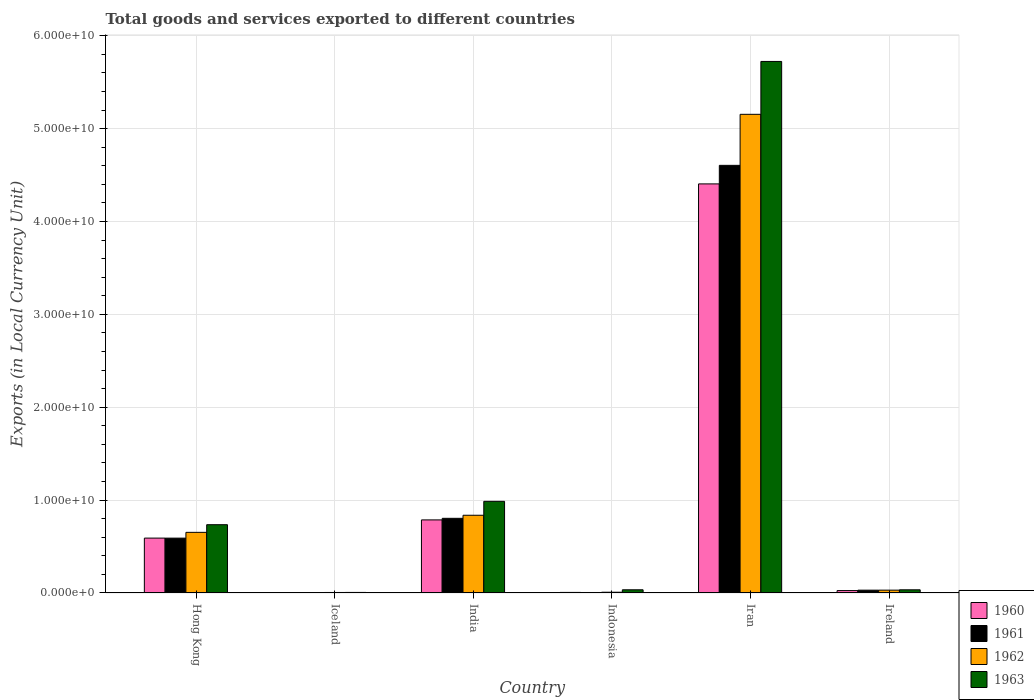How many different coloured bars are there?
Offer a very short reply. 4. How many groups of bars are there?
Your answer should be very brief. 6. Are the number of bars per tick equal to the number of legend labels?
Your answer should be compact. Yes. Are the number of bars on each tick of the X-axis equal?
Provide a short and direct response. Yes. How many bars are there on the 4th tick from the left?
Provide a succinct answer. 4. How many bars are there on the 1st tick from the right?
Provide a short and direct response. 4. What is the label of the 1st group of bars from the left?
Offer a very short reply. Hong Kong. In how many cases, is the number of bars for a given country not equal to the number of legend labels?
Make the answer very short. 0. What is the Amount of goods and services exports in 1963 in Iran?
Make the answer very short. 5.72e+1. Across all countries, what is the maximum Amount of goods and services exports in 1962?
Keep it short and to the point. 5.15e+1. Across all countries, what is the minimum Amount of goods and services exports in 1963?
Your response must be concise. 6.02e+07. In which country was the Amount of goods and services exports in 1960 maximum?
Ensure brevity in your answer.  Iran. In which country was the Amount of goods and services exports in 1960 minimum?
Provide a short and direct response. Iceland. What is the total Amount of goods and services exports in 1963 in the graph?
Your answer should be compact. 7.52e+1. What is the difference between the Amount of goods and services exports in 1961 in Indonesia and that in Iran?
Keep it short and to the point. -4.60e+1. What is the difference between the Amount of goods and services exports in 1960 in Ireland and the Amount of goods and services exports in 1962 in Hong Kong?
Ensure brevity in your answer.  -6.27e+09. What is the average Amount of goods and services exports in 1961 per country?
Keep it short and to the point. 1.01e+1. What is the difference between the Amount of goods and services exports of/in 1963 and Amount of goods and services exports of/in 1960 in Hong Kong?
Offer a terse response. 1.44e+09. What is the ratio of the Amount of goods and services exports in 1961 in Hong Kong to that in Iceland?
Provide a short and direct response. 140.21. What is the difference between the highest and the second highest Amount of goods and services exports in 1963?
Keep it short and to the point. -4.74e+1. What is the difference between the highest and the lowest Amount of goods and services exports in 1962?
Your answer should be compact. 5.15e+1. What does the 4th bar from the left in Indonesia represents?
Your answer should be very brief. 1963. What does the 1st bar from the right in Iran represents?
Provide a succinct answer. 1963. Is it the case that in every country, the sum of the Amount of goods and services exports in 1961 and Amount of goods and services exports in 1962 is greater than the Amount of goods and services exports in 1963?
Offer a terse response. No. Are all the bars in the graph horizontal?
Offer a terse response. No. Does the graph contain grids?
Provide a succinct answer. Yes. Where does the legend appear in the graph?
Ensure brevity in your answer.  Bottom right. How are the legend labels stacked?
Make the answer very short. Vertical. What is the title of the graph?
Ensure brevity in your answer.  Total goods and services exported to different countries. Does "1964" appear as one of the legend labels in the graph?
Make the answer very short. No. What is the label or title of the X-axis?
Ensure brevity in your answer.  Country. What is the label or title of the Y-axis?
Your response must be concise. Exports (in Local Currency Unit). What is the Exports (in Local Currency Unit) of 1960 in Hong Kong?
Keep it short and to the point. 5.91e+09. What is the Exports (in Local Currency Unit) of 1961 in Hong Kong?
Make the answer very short. 5.91e+09. What is the Exports (in Local Currency Unit) in 1962 in Hong Kong?
Provide a short and direct response. 6.53e+09. What is the Exports (in Local Currency Unit) in 1963 in Hong Kong?
Your answer should be very brief. 7.35e+09. What is the Exports (in Local Currency Unit) in 1960 in Iceland?
Provide a short and direct response. 3.71e+07. What is the Exports (in Local Currency Unit) of 1961 in Iceland?
Offer a terse response. 4.21e+07. What is the Exports (in Local Currency Unit) of 1962 in Iceland?
Your answer should be compact. 5.52e+07. What is the Exports (in Local Currency Unit) of 1963 in Iceland?
Your answer should be compact. 6.02e+07. What is the Exports (in Local Currency Unit) of 1960 in India?
Your response must be concise. 7.87e+09. What is the Exports (in Local Currency Unit) of 1961 in India?
Offer a terse response. 8.04e+09. What is the Exports (in Local Currency Unit) of 1962 in India?
Ensure brevity in your answer.  8.37e+09. What is the Exports (in Local Currency Unit) in 1963 in India?
Your answer should be very brief. 9.87e+09. What is the Exports (in Local Currency Unit) of 1960 in Indonesia?
Offer a very short reply. 6.20e+07. What is the Exports (in Local Currency Unit) of 1961 in Indonesia?
Ensure brevity in your answer.  5.31e+07. What is the Exports (in Local Currency Unit) of 1962 in Indonesia?
Provide a short and direct response. 8.19e+07. What is the Exports (in Local Currency Unit) of 1963 in Indonesia?
Provide a short and direct response. 3.44e+08. What is the Exports (in Local Currency Unit) of 1960 in Iran?
Provide a short and direct response. 4.41e+1. What is the Exports (in Local Currency Unit) of 1961 in Iran?
Offer a very short reply. 4.60e+1. What is the Exports (in Local Currency Unit) of 1962 in Iran?
Offer a very short reply. 5.15e+1. What is the Exports (in Local Currency Unit) of 1963 in Iran?
Offer a very short reply. 5.72e+1. What is the Exports (in Local Currency Unit) of 1960 in Ireland?
Give a very brief answer. 2.60e+08. What is the Exports (in Local Currency Unit) of 1961 in Ireland?
Keep it short and to the point. 3.04e+08. What is the Exports (in Local Currency Unit) in 1962 in Ireland?
Your answer should be very brief. 3.07e+08. What is the Exports (in Local Currency Unit) in 1963 in Ireland?
Offer a terse response. 3.43e+08. Across all countries, what is the maximum Exports (in Local Currency Unit) in 1960?
Provide a short and direct response. 4.41e+1. Across all countries, what is the maximum Exports (in Local Currency Unit) in 1961?
Your answer should be compact. 4.60e+1. Across all countries, what is the maximum Exports (in Local Currency Unit) of 1962?
Your answer should be very brief. 5.15e+1. Across all countries, what is the maximum Exports (in Local Currency Unit) of 1963?
Ensure brevity in your answer.  5.72e+1. Across all countries, what is the minimum Exports (in Local Currency Unit) in 1960?
Ensure brevity in your answer.  3.71e+07. Across all countries, what is the minimum Exports (in Local Currency Unit) in 1961?
Your response must be concise. 4.21e+07. Across all countries, what is the minimum Exports (in Local Currency Unit) in 1962?
Provide a short and direct response. 5.52e+07. Across all countries, what is the minimum Exports (in Local Currency Unit) in 1963?
Ensure brevity in your answer.  6.02e+07. What is the total Exports (in Local Currency Unit) of 1960 in the graph?
Offer a terse response. 5.82e+1. What is the total Exports (in Local Currency Unit) in 1961 in the graph?
Give a very brief answer. 6.04e+1. What is the total Exports (in Local Currency Unit) of 1962 in the graph?
Your answer should be very brief. 6.69e+1. What is the total Exports (in Local Currency Unit) of 1963 in the graph?
Keep it short and to the point. 7.52e+1. What is the difference between the Exports (in Local Currency Unit) in 1960 in Hong Kong and that in Iceland?
Provide a succinct answer. 5.87e+09. What is the difference between the Exports (in Local Currency Unit) of 1961 in Hong Kong and that in Iceland?
Provide a short and direct response. 5.87e+09. What is the difference between the Exports (in Local Currency Unit) in 1962 in Hong Kong and that in Iceland?
Your response must be concise. 6.47e+09. What is the difference between the Exports (in Local Currency Unit) in 1963 in Hong Kong and that in Iceland?
Your response must be concise. 7.29e+09. What is the difference between the Exports (in Local Currency Unit) of 1960 in Hong Kong and that in India?
Offer a very short reply. -1.96e+09. What is the difference between the Exports (in Local Currency Unit) in 1961 in Hong Kong and that in India?
Give a very brief answer. -2.13e+09. What is the difference between the Exports (in Local Currency Unit) of 1962 in Hong Kong and that in India?
Make the answer very short. -1.84e+09. What is the difference between the Exports (in Local Currency Unit) in 1963 in Hong Kong and that in India?
Make the answer very short. -2.52e+09. What is the difference between the Exports (in Local Currency Unit) in 1960 in Hong Kong and that in Indonesia?
Give a very brief answer. 5.85e+09. What is the difference between the Exports (in Local Currency Unit) in 1961 in Hong Kong and that in Indonesia?
Your response must be concise. 5.85e+09. What is the difference between the Exports (in Local Currency Unit) in 1962 in Hong Kong and that in Indonesia?
Keep it short and to the point. 6.45e+09. What is the difference between the Exports (in Local Currency Unit) in 1963 in Hong Kong and that in Indonesia?
Make the answer very short. 7.01e+09. What is the difference between the Exports (in Local Currency Unit) in 1960 in Hong Kong and that in Iran?
Your answer should be very brief. -3.81e+1. What is the difference between the Exports (in Local Currency Unit) of 1961 in Hong Kong and that in Iran?
Offer a very short reply. -4.01e+1. What is the difference between the Exports (in Local Currency Unit) of 1962 in Hong Kong and that in Iran?
Your answer should be very brief. -4.50e+1. What is the difference between the Exports (in Local Currency Unit) of 1963 in Hong Kong and that in Iran?
Provide a short and direct response. -4.99e+1. What is the difference between the Exports (in Local Currency Unit) of 1960 in Hong Kong and that in Ireland?
Keep it short and to the point. 5.65e+09. What is the difference between the Exports (in Local Currency Unit) in 1961 in Hong Kong and that in Ireland?
Your response must be concise. 5.60e+09. What is the difference between the Exports (in Local Currency Unit) of 1962 in Hong Kong and that in Ireland?
Your response must be concise. 6.22e+09. What is the difference between the Exports (in Local Currency Unit) of 1963 in Hong Kong and that in Ireland?
Your response must be concise. 7.01e+09. What is the difference between the Exports (in Local Currency Unit) of 1960 in Iceland and that in India?
Ensure brevity in your answer.  -7.83e+09. What is the difference between the Exports (in Local Currency Unit) of 1961 in Iceland and that in India?
Your response must be concise. -8.00e+09. What is the difference between the Exports (in Local Currency Unit) in 1962 in Iceland and that in India?
Provide a short and direct response. -8.31e+09. What is the difference between the Exports (in Local Currency Unit) of 1963 in Iceland and that in India?
Provide a short and direct response. -9.81e+09. What is the difference between the Exports (in Local Currency Unit) in 1960 in Iceland and that in Indonesia?
Keep it short and to the point. -2.49e+07. What is the difference between the Exports (in Local Currency Unit) of 1961 in Iceland and that in Indonesia?
Keep it short and to the point. -1.10e+07. What is the difference between the Exports (in Local Currency Unit) in 1962 in Iceland and that in Indonesia?
Your response must be concise. -2.67e+07. What is the difference between the Exports (in Local Currency Unit) in 1963 in Iceland and that in Indonesia?
Provide a short and direct response. -2.84e+08. What is the difference between the Exports (in Local Currency Unit) of 1960 in Iceland and that in Iran?
Provide a short and direct response. -4.40e+1. What is the difference between the Exports (in Local Currency Unit) of 1961 in Iceland and that in Iran?
Ensure brevity in your answer.  -4.60e+1. What is the difference between the Exports (in Local Currency Unit) of 1962 in Iceland and that in Iran?
Provide a succinct answer. -5.15e+1. What is the difference between the Exports (in Local Currency Unit) of 1963 in Iceland and that in Iran?
Provide a short and direct response. -5.72e+1. What is the difference between the Exports (in Local Currency Unit) in 1960 in Iceland and that in Ireland?
Your answer should be compact. -2.23e+08. What is the difference between the Exports (in Local Currency Unit) of 1961 in Iceland and that in Ireland?
Make the answer very short. -2.62e+08. What is the difference between the Exports (in Local Currency Unit) of 1962 in Iceland and that in Ireland?
Your answer should be compact. -2.51e+08. What is the difference between the Exports (in Local Currency Unit) in 1963 in Iceland and that in Ireland?
Offer a very short reply. -2.83e+08. What is the difference between the Exports (in Local Currency Unit) in 1960 in India and that in Indonesia?
Provide a succinct answer. 7.81e+09. What is the difference between the Exports (in Local Currency Unit) in 1961 in India and that in Indonesia?
Offer a very short reply. 7.99e+09. What is the difference between the Exports (in Local Currency Unit) of 1962 in India and that in Indonesia?
Give a very brief answer. 8.29e+09. What is the difference between the Exports (in Local Currency Unit) of 1963 in India and that in Indonesia?
Your response must be concise. 9.53e+09. What is the difference between the Exports (in Local Currency Unit) in 1960 in India and that in Iran?
Provide a short and direct response. -3.62e+1. What is the difference between the Exports (in Local Currency Unit) in 1961 in India and that in Iran?
Your answer should be compact. -3.80e+1. What is the difference between the Exports (in Local Currency Unit) of 1962 in India and that in Iran?
Offer a terse response. -4.32e+1. What is the difference between the Exports (in Local Currency Unit) of 1963 in India and that in Iran?
Give a very brief answer. -4.74e+1. What is the difference between the Exports (in Local Currency Unit) in 1960 in India and that in Ireland?
Your response must be concise. 7.61e+09. What is the difference between the Exports (in Local Currency Unit) of 1961 in India and that in Ireland?
Give a very brief answer. 7.74e+09. What is the difference between the Exports (in Local Currency Unit) of 1962 in India and that in Ireland?
Keep it short and to the point. 8.06e+09. What is the difference between the Exports (in Local Currency Unit) in 1963 in India and that in Ireland?
Your answer should be compact. 9.53e+09. What is the difference between the Exports (in Local Currency Unit) of 1960 in Indonesia and that in Iran?
Offer a very short reply. -4.40e+1. What is the difference between the Exports (in Local Currency Unit) of 1961 in Indonesia and that in Iran?
Give a very brief answer. -4.60e+1. What is the difference between the Exports (in Local Currency Unit) in 1962 in Indonesia and that in Iran?
Offer a terse response. -5.15e+1. What is the difference between the Exports (in Local Currency Unit) of 1963 in Indonesia and that in Iran?
Offer a very short reply. -5.69e+1. What is the difference between the Exports (in Local Currency Unit) of 1960 in Indonesia and that in Ireland?
Your answer should be compact. -1.98e+08. What is the difference between the Exports (in Local Currency Unit) of 1961 in Indonesia and that in Ireland?
Your response must be concise. -2.51e+08. What is the difference between the Exports (in Local Currency Unit) of 1962 in Indonesia and that in Ireland?
Offer a terse response. -2.25e+08. What is the difference between the Exports (in Local Currency Unit) of 1963 in Indonesia and that in Ireland?
Your answer should be very brief. 1.22e+06. What is the difference between the Exports (in Local Currency Unit) of 1960 in Iran and that in Ireland?
Your response must be concise. 4.38e+1. What is the difference between the Exports (in Local Currency Unit) in 1961 in Iran and that in Ireland?
Offer a terse response. 4.57e+1. What is the difference between the Exports (in Local Currency Unit) of 1962 in Iran and that in Ireland?
Give a very brief answer. 5.12e+1. What is the difference between the Exports (in Local Currency Unit) in 1963 in Iran and that in Ireland?
Your answer should be compact. 5.69e+1. What is the difference between the Exports (in Local Currency Unit) of 1960 in Hong Kong and the Exports (in Local Currency Unit) of 1961 in Iceland?
Provide a short and direct response. 5.87e+09. What is the difference between the Exports (in Local Currency Unit) of 1960 in Hong Kong and the Exports (in Local Currency Unit) of 1962 in Iceland?
Provide a succinct answer. 5.85e+09. What is the difference between the Exports (in Local Currency Unit) of 1960 in Hong Kong and the Exports (in Local Currency Unit) of 1963 in Iceland?
Provide a short and direct response. 5.85e+09. What is the difference between the Exports (in Local Currency Unit) in 1961 in Hong Kong and the Exports (in Local Currency Unit) in 1962 in Iceland?
Offer a very short reply. 5.85e+09. What is the difference between the Exports (in Local Currency Unit) of 1961 in Hong Kong and the Exports (in Local Currency Unit) of 1963 in Iceland?
Your answer should be compact. 5.85e+09. What is the difference between the Exports (in Local Currency Unit) of 1962 in Hong Kong and the Exports (in Local Currency Unit) of 1963 in Iceland?
Give a very brief answer. 6.47e+09. What is the difference between the Exports (in Local Currency Unit) in 1960 in Hong Kong and the Exports (in Local Currency Unit) in 1961 in India?
Provide a succinct answer. -2.13e+09. What is the difference between the Exports (in Local Currency Unit) in 1960 in Hong Kong and the Exports (in Local Currency Unit) in 1962 in India?
Provide a succinct answer. -2.46e+09. What is the difference between the Exports (in Local Currency Unit) of 1960 in Hong Kong and the Exports (in Local Currency Unit) of 1963 in India?
Provide a succinct answer. -3.96e+09. What is the difference between the Exports (in Local Currency Unit) of 1961 in Hong Kong and the Exports (in Local Currency Unit) of 1962 in India?
Your answer should be very brief. -2.46e+09. What is the difference between the Exports (in Local Currency Unit) in 1961 in Hong Kong and the Exports (in Local Currency Unit) in 1963 in India?
Make the answer very short. -3.96e+09. What is the difference between the Exports (in Local Currency Unit) in 1962 in Hong Kong and the Exports (in Local Currency Unit) in 1963 in India?
Provide a short and direct response. -3.34e+09. What is the difference between the Exports (in Local Currency Unit) of 1960 in Hong Kong and the Exports (in Local Currency Unit) of 1961 in Indonesia?
Your answer should be compact. 5.86e+09. What is the difference between the Exports (in Local Currency Unit) in 1960 in Hong Kong and the Exports (in Local Currency Unit) in 1962 in Indonesia?
Provide a short and direct response. 5.83e+09. What is the difference between the Exports (in Local Currency Unit) of 1960 in Hong Kong and the Exports (in Local Currency Unit) of 1963 in Indonesia?
Your response must be concise. 5.57e+09. What is the difference between the Exports (in Local Currency Unit) in 1961 in Hong Kong and the Exports (in Local Currency Unit) in 1962 in Indonesia?
Your answer should be very brief. 5.83e+09. What is the difference between the Exports (in Local Currency Unit) of 1961 in Hong Kong and the Exports (in Local Currency Unit) of 1963 in Indonesia?
Provide a short and direct response. 5.56e+09. What is the difference between the Exports (in Local Currency Unit) in 1962 in Hong Kong and the Exports (in Local Currency Unit) in 1963 in Indonesia?
Keep it short and to the point. 6.19e+09. What is the difference between the Exports (in Local Currency Unit) in 1960 in Hong Kong and the Exports (in Local Currency Unit) in 1961 in Iran?
Offer a terse response. -4.01e+1. What is the difference between the Exports (in Local Currency Unit) in 1960 in Hong Kong and the Exports (in Local Currency Unit) in 1962 in Iran?
Provide a short and direct response. -4.56e+1. What is the difference between the Exports (in Local Currency Unit) of 1960 in Hong Kong and the Exports (in Local Currency Unit) of 1963 in Iran?
Provide a succinct answer. -5.13e+1. What is the difference between the Exports (in Local Currency Unit) of 1961 in Hong Kong and the Exports (in Local Currency Unit) of 1962 in Iran?
Provide a succinct answer. -4.56e+1. What is the difference between the Exports (in Local Currency Unit) in 1961 in Hong Kong and the Exports (in Local Currency Unit) in 1963 in Iran?
Ensure brevity in your answer.  -5.13e+1. What is the difference between the Exports (in Local Currency Unit) in 1962 in Hong Kong and the Exports (in Local Currency Unit) in 1963 in Iran?
Keep it short and to the point. -5.07e+1. What is the difference between the Exports (in Local Currency Unit) in 1960 in Hong Kong and the Exports (in Local Currency Unit) in 1961 in Ireland?
Provide a succinct answer. 5.61e+09. What is the difference between the Exports (in Local Currency Unit) in 1960 in Hong Kong and the Exports (in Local Currency Unit) in 1962 in Ireland?
Offer a terse response. 5.60e+09. What is the difference between the Exports (in Local Currency Unit) of 1960 in Hong Kong and the Exports (in Local Currency Unit) of 1963 in Ireland?
Ensure brevity in your answer.  5.57e+09. What is the difference between the Exports (in Local Currency Unit) of 1961 in Hong Kong and the Exports (in Local Currency Unit) of 1962 in Ireland?
Offer a very short reply. 5.60e+09. What is the difference between the Exports (in Local Currency Unit) in 1961 in Hong Kong and the Exports (in Local Currency Unit) in 1963 in Ireland?
Your answer should be very brief. 5.56e+09. What is the difference between the Exports (in Local Currency Unit) of 1962 in Hong Kong and the Exports (in Local Currency Unit) of 1963 in Ireland?
Offer a terse response. 6.19e+09. What is the difference between the Exports (in Local Currency Unit) in 1960 in Iceland and the Exports (in Local Currency Unit) in 1961 in India?
Keep it short and to the point. -8.00e+09. What is the difference between the Exports (in Local Currency Unit) of 1960 in Iceland and the Exports (in Local Currency Unit) of 1962 in India?
Your response must be concise. -8.33e+09. What is the difference between the Exports (in Local Currency Unit) in 1960 in Iceland and the Exports (in Local Currency Unit) in 1963 in India?
Offer a very short reply. -9.83e+09. What is the difference between the Exports (in Local Currency Unit) of 1961 in Iceland and the Exports (in Local Currency Unit) of 1962 in India?
Make the answer very short. -8.33e+09. What is the difference between the Exports (in Local Currency Unit) in 1961 in Iceland and the Exports (in Local Currency Unit) in 1963 in India?
Offer a terse response. -9.83e+09. What is the difference between the Exports (in Local Currency Unit) of 1962 in Iceland and the Exports (in Local Currency Unit) of 1963 in India?
Provide a succinct answer. -9.81e+09. What is the difference between the Exports (in Local Currency Unit) in 1960 in Iceland and the Exports (in Local Currency Unit) in 1961 in Indonesia?
Offer a terse response. -1.60e+07. What is the difference between the Exports (in Local Currency Unit) in 1960 in Iceland and the Exports (in Local Currency Unit) in 1962 in Indonesia?
Your answer should be very brief. -4.48e+07. What is the difference between the Exports (in Local Currency Unit) of 1960 in Iceland and the Exports (in Local Currency Unit) of 1963 in Indonesia?
Ensure brevity in your answer.  -3.07e+08. What is the difference between the Exports (in Local Currency Unit) of 1961 in Iceland and the Exports (in Local Currency Unit) of 1962 in Indonesia?
Make the answer very short. -3.98e+07. What is the difference between the Exports (in Local Currency Unit) in 1961 in Iceland and the Exports (in Local Currency Unit) in 1963 in Indonesia?
Provide a short and direct response. -3.02e+08. What is the difference between the Exports (in Local Currency Unit) in 1962 in Iceland and the Exports (in Local Currency Unit) in 1963 in Indonesia?
Your answer should be compact. -2.89e+08. What is the difference between the Exports (in Local Currency Unit) of 1960 in Iceland and the Exports (in Local Currency Unit) of 1961 in Iran?
Your answer should be compact. -4.60e+1. What is the difference between the Exports (in Local Currency Unit) of 1960 in Iceland and the Exports (in Local Currency Unit) of 1962 in Iran?
Give a very brief answer. -5.15e+1. What is the difference between the Exports (in Local Currency Unit) in 1960 in Iceland and the Exports (in Local Currency Unit) in 1963 in Iran?
Ensure brevity in your answer.  -5.72e+1. What is the difference between the Exports (in Local Currency Unit) of 1961 in Iceland and the Exports (in Local Currency Unit) of 1962 in Iran?
Offer a terse response. -5.15e+1. What is the difference between the Exports (in Local Currency Unit) of 1961 in Iceland and the Exports (in Local Currency Unit) of 1963 in Iran?
Provide a succinct answer. -5.72e+1. What is the difference between the Exports (in Local Currency Unit) in 1962 in Iceland and the Exports (in Local Currency Unit) in 1963 in Iran?
Your response must be concise. -5.72e+1. What is the difference between the Exports (in Local Currency Unit) of 1960 in Iceland and the Exports (in Local Currency Unit) of 1961 in Ireland?
Your answer should be very brief. -2.67e+08. What is the difference between the Exports (in Local Currency Unit) in 1960 in Iceland and the Exports (in Local Currency Unit) in 1962 in Ireland?
Keep it short and to the point. -2.69e+08. What is the difference between the Exports (in Local Currency Unit) in 1960 in Iceland and the Exports (in Local Currency Unit) in 1963 in Ireland?
Provide a short and direct response. -3.06e+08. What is the difference between the Exports (in Local Currency Unit) in 1961 in Iceland and the Exports (in Local Currency Unit) in 1962 in Ireland?
Ensure brevity in your answer.  -2.64e+08. What is the difference between the Exports (in Local Currency Unit) of 1961 in Iceland and the Exports (in Local Currency Unit) of 1963 in Ireland?
Make the answer very short. -3.01e+08. What is the difference between the Exports (in Local Currency Unit) of 1962 in Iceland and the Exports (in Local Currency Unit) of 1963 in Ireland?
Your response must be concise. -2.88e+08. What is the difference between the Exports (in Local Currency Unit) of 1960 in India and the Exports (in Local Currency Unit) of 1961 in Indonesia?
Your answer should be compact. 7.82e+09. What is the difference between the Exports (in Local Currency Unit) of 1960 in India and the Exports (in Local Currency Unit) of 1962 in Indonesia?
Your answer should be very brief. 7.79e+09. What is the difference between the Exports (in Local Currency Unit) of 1960 in India and the Exports (in Local Currency Unit) of 1963 in Indonesia?
Make the answer very short. 7.53e+09. What is the difference between the Exports (in Local Currency Unit) of 1961 in India and the Exports (in Local Currency Unit) of 1962 in Indonesia?
Offer a terse response. 7.96e+09. What is the difference between the Exports (in Local Currency Unit) of 1961 in India and the Exports (in Local Currency Unit) of 1963 in Indonesia?
Your response must be concise. 7.70e+09. What is the difference between the Exports (in Local Currency Unit) in 1962 in India and the Exports (in Local Currency Unit) in 1963 in Indonesia?
Ensure brevity in your answer.  8.03e+09. What is the difference between the Exports (in Local Currency Unit) of 1960 in India and the Exports (in Local Currency Unit) of 1961 in Iran?
Ensure brevity in your answer.  -3.82e+1. What is the difference between the Exports (in Local Currency Unit) of 1960 in India and the Exports (in Local Currency Unit) of 1962 in Iran?
Provide a short and direct response. -4.37e+1. What is the difference between the Exports (in Local Currency Unit) in 1960 in India and the Exports (in Local Currency Unit) in 1963 in Iran?
Your response must be concise. -4.94e+1. What is the difference between the Exports (in Local Currency Unit) in 1961 in India and the Exports (in Local Currency Unit) in 1962 in Iran?
Offer a very short reply. -4.35e+1. What is the difference between the Exports (in Local Currency Unit) in 1961 in India and the Exports (in Local Currency Unit) in 1963 in Iran?
Provide a succinct answer. -4.92e+1. What is the difference between the Exports (in Local Currency Unit) in 1962 in India and the Exports (in Local Currency Unit) in 1963 in Iran?
Ensure brevity in your answer.  -4.89e+1. What is the difference between the Exports (in Local Currency Unit) in 1960 in India and the Exports (in Local Currency Unit) in 1961 in Ireland?
Your answer should be very brief. 7.57e+09. What is the difference between the Exports (in Local Currency Unit) of 1960 in India and the Exports (in Local Currency Unit) of 1962 in Ireland?
Ensure brevity in your answer.  7.56e+09. What is the difference between the Exports (in Local Currency Unit) of 1960 in India and the Exports (in Local Currency Unit) of 1963 in Ireland?
Give a very brief answer. 7.53e+09. What is the difference between the Exports (in Local Currency Unit) of 1961 in India and the Exports (in Local Currency Unit) of 1962 in Ireland?
Provide a short and direct response. 7.73e+09. What is the difference between the Exports (in Local Currency Unit) in 1961 in India and the Exports (in Local Currency Unit) in 1963 in Ireland?
Offer a very short reply. 7.70e+09. What is the difference between the Exports (in Local Currency Unit) of 1962 in India and the Exports (in Local Currency Unit) of 1963 in Ireland?
Your response must be concise. 8.03e+09. What is the difference between the Exports (in Local Currency Unit) in 1960 in Indonesia and the Exports (in Local Currency Unit) in 1961 in Iran?
Your answer should be very brief. -4.60e+1. What is the difference between the Exports (in Local Currency Unit) in 1960 in Indonesia and the Exports (in Local Currency Unit) in 1962 in Iran?
Your answer should be compact. -5.15e+1. What is the difference between the Exports (in Local Currency Unit) of 1960 in Indonesia and the Exports (in Local Currency Unit) of 1963 in Iran?
Give a very brief answer. -5.72e+1. What is the difference between the Exports (in Local Currency Unit) of 1961 in Indonesia and the Exports (in Local Currency Unit) of 1962 in Iran?
Give a very brief answer. -5.15e+1. What is the difference between the Exports (in Local Currency Unit) of 1961 in Indonesia and the Exports (in Local Currency Unit) of 1963 in Iran?
Make the answer very short. -5.72e+1. What is the difference between the Exports (in Local Currency Unit) of 1962 in Indonesia and the Exports (in Local Currency Unit) of 1963 in Iran?
Your answer should be very brief. -5.72e+1. What is the difference between the Exports (in Local Currency Unit) in 1960 in Indonesia and the Exports (in Local Currency Unit) in 1961 in Ireland?
Provide a succinct answer. -2.42e+08. What is the difference between the Exports (in Local Currency Unit) of 1960 in Indonesia and the Exports (in Local Currency Unit) of 1962 in Ireland?
Your answer should be compact. -2.45e+08. What is the difference between the Exports (in Local Currency Unit) in 1960 in Indonesia and the Exports (in Local Currency Unit) in 1963 in Ireland?
Make the answer very short. -2.81e+08. What is the difference between the Exports (in Local Currency Unit) of 1961 in Indonesia and the Exports (in Local Currency Unit) of 1962 in Ireland?
Offer a terse response. -2.53e+08. What is the difference between the Exports (in Local Currency Unit) of 1961 in Indonesia and the Exports (in Local Currency Unit) of 1963 in Ireland?
Give a very brief answer. -2.90e+08. What is the difference between the Exports (in Local Currency Unit) in 1962 in Indonesia and the Exports (in Local Currency Unit) in 1963 in Ireland?
Ensure brevity in your answer.  -2.61e+08. What is the difference between the Exports (in Local Currency Unit) in 1960 in Iran and the Exports (in Local Currency Unit) in 1961 in Ireland?
Make the answer very short. 4.37e+1. What is the difference between the Exports (in Local Currency Unit) in 1960 in Iran and the Exports (in Local Currency Unit) in 1962 in Ireland?
Keep it short and to the point. 4.37e+1. What is the difference between the Exports (in Local Currency Unit) of 1960 in Iran and the Exports (in Local Currency Unit) of 1963 in Ireland?
Offer a very short reply. 4.37e+1. What is the difference between the Exports (in Local Currency Unit) in 1961 in Iran and the Exports (in Local Currency Unit) in 1962 in Ireland?
Keep it short and to the point. 4.57e+1. What is the difference between the Exports (in Local Currency Unit) of 1961 in Iran and the Exports (in Local Currency Unit) of 1963 in Ireland?
Provide a succinct answer. 4.57e+1. What is the difference between the Exports (in Local Currency Unit) of 1962 in Iran and the Exports (in Local Currency Unit) of 1963 in Ireland?
Your answer should be very brief. 5.12e+1. What is the average Exports (in Local Currency Unit) in 1960 per country?
Keep it short and to the point. 9.70e+09. What is the average Exports (in Local Currency Unit) in 1961 per country?
Make the answer very short. 1.01e+1. What is the average Exports (in Local Currency Unit) of 1962 per country?
Your response must be concise. 1.11e+1. What is the average Exports (in Local Currency Unit) of 1963 per country?
Your response must be concise. 1.25e+1. What is the difference between the Exports (in Local Currency Unit) in 1960 and Exports (in Local Currency Unit) in 1961 in Hong Kong?
Offer a terse response. 2.67e+06. What is the difference between the Exports (in Local Currency Unit) of 1960 and Exports (in Local Currency Unit) of 1962 in Hong Kong?
Your response must be concise. -6.20e+08. What is the difference between the Exports (in Local Currency Unit) in 1960 and Exports (in Local Currency Unit) in 1963 in Hong Kong?
Your response must be concise. -1.44e+09. What is the difference between the Exports (in Local Currency Unit) of 1961 and Exports (in Local Currency Unit) of 1962 in Hong Kong?
Your answer should be very brief. -6.23e+08. What is the difference between the Exports (in Local Currency Unit) in 1961 and Exports (in Local Currency Unit) in 1963 in Hong Kong?
Offer a very short reply. -1.45e+09. What is the difference between the Exports (in Local Currency Unit) of 1962 and Exports (in Local Currency Unit) of 1963 in Hong Kong?
Your answer should be compact. -8.24e+08. What is the difference between the Exports (in Local Currency Unit) of 1960 and Exports (in Local Currency Unit) of 1961 in Iceland?
Offer a very short reply. -5.02e+06. What is the difference between the Exports (in Local Currency Unit) of 1960 and Exports (in Local Currency Unit) of 1962 in Iceland?
Offer a terse response. -1.81e+07. What is the difference between the Exports (in Local Currency Unit) in 1960 and Exports (in Local Currency Unit) in 1963 in Iceland?
Make the answer very short. -2.31e+07. What is the difference between the Exports (in Local Currency Unit) in 1961 and Exports (in Local Currency Unit) in 1962 in Iceland?
Keep it short and to the point. -1.30e+07. What is the difference between the Exports (in Local Currency Unit) in 1961 and Exports (in Local Currency Unit) in 1963 in Iceland?
Your answer should be compact. -1.81e+07. What is the difference between the Exports (in Local Currency Unit) in 1962 and Exports (in Local Currency Unit) in 1963 in Iceland?
Offer a terse response. -5.02e+06. What is the difference between the Exports (in Local Currency Unit) of 1960 and Exports (in Local Currency Unit) of 1961 in India?
Provide a short and direct response. -1.70e+08. What is the difference between the Exports (in Local Currency Unit) of 1960 and Exports (in Local Currency Unit) of 1962 in India?
Provide a short and direct response. -5.00e+08. What is the difference between the Exports (in Local Currency Unit) of 1960 and Exports (in Local Currency Unit) of 1963 in India?
Your answer should be compact. -2.00e+09. What is the difference between the Exports (in Local Currency Unit) in 1961 and Exports (in Local Currency Unit) in 1962 in India?
Your response must be concise. -3.30e+08. What is the difference between the Exports (in Local Currency Unit) of 1961 and Exports (in Local Currency Unit) of 1963 in India?
Ensure brevity in your answer.  -1.83e+09. What is the difference between the Exports (in Local Currency Unit) in 1962 and Exports (in Local Currency Unit) in 1963 in India?
Offer a very short reply. -1.50e+09. What is the difference between the Exports (in Local Currency Unit) of 1960 and Exports (in Local Currency Unit) of 1961 in Indonesia?
Offer a terse response. 8.85e+06. What is the difference between the Exports (in Local Currency Unit) in 1960 and Exports (in Local Currency Unit) in 1962 in Indonesia?
Offer a very short reply. -1.99e+07. What is the difference between the Exports (in Local Currency Unit) of 1960 and Exports (in Local Currency Unit) of 1963 in Indonesia?
Keep it short and to the point. -2.82e+08. What is the difference between the Exports (in Local Currency Unit) of 1961 and Exports (in Local Currency Unit) of 1962 in Indonesia?
Keep it short and to the point. -2.88e+07. What is the difference between the Exports (in Local Currency Unit) of 1961 and Exports (in Local Currency Unit) of 1963 in Indonesia?
Offer a terse response. -2.91e+08. What is the difference between the Exports (in Local Currency Unit) of 1962 and Exports (in Local Currency Unit) of 1963 in Indonesia?
Provide a succinct answer. -2.62e+08. What is the difference between the Exports (in Local Currency Unit) in 1960 and Exports (in Local Currency Unit) in 1961 in Iran?
Keep it short and to the point. -2.00e+09. What is the difference between the Exports (in Local Currency Unit) in 1960 and Exports (in Local Currency Unit) in 1962 in Iran?
Offer a terse response. -7.49e+09. What is the difference between the Exports (in Local Currency Unit) of 1960 and Exports (in Local Currency Unit) of 1963 in Iran?
Offer a terse response. -1.32e+1. What is the difference between the Exports (in Local Currency Unit) in 1961 and Exports (in Local Currency Unit) in 1962 in Iran?
Ensure brevity in your answer.  -5.49e+09. What is the difference between the Exports (in Local Currency Unit) in 1961 and Exports (in Local Currency Unit) in 1963 in Iran?
Your answer should be very brief. -1.12e+1. What is the difference between the Exports (in Local Currency Unit) of 1962 and Exports (in Local Currency Unit) of 1963 in Iran?
Provide a short and direct response. -5.69e+09. What is the difference between the Exports (in Local Currency Unit) in 1960 and Exports (in Local Currency Unit) in 1961 in Ireland?
Your response must be concise. -4.43e+07. What is the difference between the Exports (in Local Currency Unit) in 1960 and Exports (in Local Currency Unit) in 1962 in Ireland?
Keep it short and to the point. -4.69e+07. What is the difference between the Exports (in Local Currency Unit) in 1960 and Exports (in Local Currency Unit) in 1963 in Ireland?
Your response must be concise. -8.33e+07. What is the difference between the Exports (in Local Currency Unit) of 1961 and Exports (in Local Currency Unit) of 1962 in Ireland?
Your answer should be compact. -2.58e+06. What is the difference between the Exports (in Local Currency Unit) of 1961 and Exports (in Local Currency Unit) of 1963 in Ireland?
Ensure brevity in your answer.  -3.90e+07. What is the difference between the Exports (in Local Currency Unit) in 1962 and Exports (in Local Currency Unit) in 1963 in Ireland?
Provide a short and direct response. -3.64e+07. What is the ratio of the Exports (in Local Currency Unit) of 1960 in Hong Kong to that in Iceland?
Provide a short and direct response. 159.23. What is the ratio of the Exports (in Local Currency Unit) in 1961 in Hong Kong to that in Iceland?
Your answer should be compact. 140.21. What is the ratio of the Exports (in Local Currency Unit) in 1962 in Hong Kong to that in Iceland?
Give a very brief answer. 118.35. What is the ratio of the Exports (in Local Currency Unit) in 1963 in Hong Kong to that in Iceland?
Provide a short and direct response. 122.18. What is the ratio of the Exports (in Local Currency Unit) of 1960 in Hong Kong to that in India?
Your response must be concise. 0.75. What is the ratio of the Exports (in Local Currency Unit) in 1961 in Hong Kong to that in India?
Make the answer very short. 0.73. What is the ratio of the Exports (in Local Currency Unit) in 1962 in Hong Kong to that in India?
Your answer should be very brief. 0.78. What is the ratio of the Exports (in Local Currency Unit) of 1963 in Hong Kong to that in India?
Your answer should be very brief. 0.75. What is the ratio of the Exports (in Local Currency Unit) in 1960 in Hong Kong to that in Indonesia?
Offer a terse response. 95.35. What is the ratio of the Exports (in Local Currency Unit) of 1961 in Hong Kong to that in Indonesia?
Your answer should be compact. 111.19. What is the ratio of the Exports (in Local Currency Unit) of 1962 in Hong Kong to that in Indonesia?
Provide a short and direct response. 79.73. What is the ratio of the Exports (in Local Currency Unit) of 1963 in Hong Kong to that in Indonesia?
Provide a short and direct response. 21.36. What is the ratio of the Exports (in Local Currency Unit) of 1960 in Hong Kong to that in Iran?
Your answer should be very brief. 0.13. What is the ratio of the Exports (in Local Currency Unit) of 1961 in Hong Kong to that in Iran?
Offer a terse response. 0.13. What is the ratio of the Exports (in Local Currency Unit) of 1962 in Hong Kong to that in Iran?
Provide a short and direct response. 0.13. What is the ratio of the Exports (in Local Currency Unit) of 1963 in Hong Kong to that in Iran?
Your response must be concise. 0.13. What is the ratio of the Exports (in Local Currency Unit) in 1960 in Hong Kong to that in Ireland?
Give a very brief answer. 22.76. What is the ratio of the Exports (in Local Currency Unit) of 1961 in Hong Kong to that in Ireland?
Your response must be concise. 19.43. What is the ratio of the Exports (in Local Currency Unit) of 1962 in Hong Kong to that in Ireland?
Offer a very short reply. 21.3. What is the ratio of the Exports (in Local Currency Unit) in 1963 in Hong Kong to that in Ireland?
Provide a succinct answer. 21.44. What is the ratio of the Exports (in Local Currency Unit) of 1960 in Iceland to that in India?
Offer a very short reply. 0. What is the ratio of the Exports (in Local Currency Unit) in 1961 in Iceland to that in India?
Make the answer very short. 0.01. What is the ratio of the Exports (in Local Currency Unit) in 1962 in Iceland to that in India?
Provide a succinct answer. 0.01. What is the ratio of the Exports (in Local Currency Unit) in 1963 in Iceland to that in India?
Make the answer very short. 0.01. What is the ratio of the Exports (in Local Currency Unit) of 1960 in Iceland to that in Indonesia?
Offer a terse response. 0.6. What is the ratio of the Exports (in Local Currency Unit) of 1961 in Iceland to that in Indonesia?
Provide a short and direct response. 0.79. What is the ratio of the Exports (in Local Currency Unit) in 1962 in Iceland to that in Indonesia?
Offer a terse response. 0.67. What is the ratio of the Exports (in Local Currency Unit) of 1963 in Iceland to that in Indonesia?
Offer a terse response. 0.17. What is the ratio of the Exports (in Local Currency Unit) in 1960 in Iceland to that in Iran?
Your response must be concise. 0. What is the ratio of the Exports (in Local Currency Unit) of 1961 in Iceland to that in Iran?
Offer a very short reply. 0. What is the ratio of the Exports (in Local Currency Unit) in 1962 in Iceland to that in Iran?
Make the answer very short. 0. What is the ratio of the Exports (in Local Currency Unit) in 1963 in Iceland to that in Iran?
Provide a short and direct response. 0. What is the ratio of the Exports (in Local Currency Unit) of 1960 in Iceland to that in Ireland?
Make the answer very short. 0.14. What is the ratio of the Exports (in Local Currency Unit) in 1961 in Iceland to that in Ireland?
Keep it short and to the point. 0.14. What is the ratio of the Exports (in Local Currency Unit) in 1962 in Iceland to that in Ireland?
Give a very brief answer. 0.18. What is the ratio of the Exports (in Local Currency Unit) of 1963 in Iceland to that in Ireland?
Your answer should be very brief. 0.18. What is the ratio of the Exports (in Local Currency Unit) in 1960 in India to that in Indonesia?
Give a very brief answer. 126.97. What is the ratio of the Exports (in Local Currency Unit) of 1961 in India to that in Indonesia?
Provide a succinct answer. 151.34. What is the ratio of the Exports (in Local Currency Unit) of 1962 in India to that in Indonesia?
Give a very brief answer. 102.19. What is the ratio of the Exports (in Local Currency Unit) in 1963 in India to that in Indonesia?
Your answer should be compact. 28.67. What is the ratio of the Exports (in Local Currency Unit) in 1960 in India to that in Iran?
Provide a short and direct response. 0.18. What is the ratio of the Exports (in Local Currency Unit) in 1961 in India to that in Iran?
Make the answer very short. 0.17. What is the ratio of the Exports (in Local Currency Unit) in 1962 in India to that in Iran?
Your answer should be very brief. 0.16. What is the ratio of the Exports (in Local Currency Unit) of 1963 in India to that in Iran?
Give a very brief answer. 0.17. What is the ratio of the Exports (in Local Currency Unit) in 1960 in India to that in Ireland?
Your response must be concise. 30.31. What is the ratio of the Exports (in Local Currency Unit) in 1961 in India to that in Ireland?
Give a very brief answer. 26.45. What is the ratio of the Exports (in Local Currency Unit) in 1962 in India to that in Ireland?
Your response must be concise. 27.3. What is the ratio of the Exports (in Local Currency Unit) in 1963 in India to that in Ireland?
Your response must be concise. 28.78. What is the ratio of the Exports (in Local Currency Unit) in 1960 in Indonesia to that in Iran?
Provide a short and direct response. 0. What is the ratio of the Exports (in Local Currency Unit) in 1961 in Indonesia to that in Iran?
Make the answer very short. 0. What is the ratio of the Exports (in Local Currency Unit) in 1962 in Indonesia to that in Iran?
Give a very brief answer. 0. What is the ratio of the Exports (in Local Currency Unit) in 1963 in Indonesia to that in Iran?
Keep it short and to the point. 0.01. What is the ratio of the Exports (in Local Currency Unit) in 1960 in Indonesia to that in Ireland?
Offer a terse response. 0.24. What is the ratio of the Exports (in Local Currency Unit) of 1961 in Indonesia to that in Ireland?
Ensure brevity in your answer.  0.17. What is the ratio of the Exports (in Local Currency Unit) of 1962 in Indonesia to that in Ireland?
Your answer should be compact. 0.27. What is the ratio of the Exports (in Local Currency Unit) in 1963 in Indonesia to that in Ireland?
Your response must be concise. 1. What is the ratio of the Exports (in Local Currency Unit) in 1960 in Iran to that in Ireland?
Offer a terse response. 169.64. What is the ratio of the Exports (in Local Currency Unit) in 1961 in Iran to that in Ireland?
Offer a terse response. 151.49. What is the ratio of the Exports (in Local Currency Unit) of 1962 in Iran to that in Ireland?
Your answer should be compact. 168.13. What is the ratio of the Exports (in Local Currency Unit) of 1963 in Iran to that in Ireland?
Your answer should be compact. 166.87. What is the difference between the highest and the second highest Exports (in Local Currency Unit) in 1960?
Offer a very short reply. 3.62e+1. What is the difference between the highest and the second highest Exports (in Local Currency Unit) of 1961?
Offer a very short reply. 3.80e+1. What is the difference between the highest and the second highest Exports (in Local Currency Unit) in 1962?
Offer a terse response. 4.32e+1. What is the difference between the highest and the second highest Exports (in Local Currency Unit) in 1963?
Your answer should be very brief. 4.74e+1. What is the difference between the highest and the lowest Exports (in Local Currency Unit) in 1960?
Offer a terse response. 4.40e+1. What is the difference between the highest and the lowest Exports (in Local Currency Unit) of 1961?
Keep it short and to the point. 4.60e+1. What is the difference between the highest and the lowest Exports (in Local Currency Unit) of 1962?
Provide a short and direct response. 5.15e+1. What is the difference between the highest and the lowest Exports (in Local Currency Unit) of 1963?
Offer a terse response. 5.72e+1. 